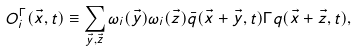Convert formula to latex. <formula><loc_0><loc_0><loc_500><loc_500>O ^ { \Gamma } _ { i } ( \vec { x } , t ) \equiv \sum _ { \vec { y } , \vec { z } } \omega _ { i } ( \vec { y } ) \omega _ { i } ( \vec { z } ) \bar { q } ( \vec { x } + \vec { y } , t ) \Gamma q ( \vec { x } + \vec { z } , t ) ,</formula> 